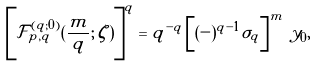<formula> <loc_0><loc_0><loc_500><loc_500>\left [ \mathcal { F } _ { p , q } ^ { ( q ; 0 ) } ( \frac { m } q ; \, \zeta ) \right ] ^ { q } = q ^ { - q } \left [ ( - ) ^ { q - 1 } \sigma _ { q } \right ] ^ { m } \, y _ { 0 } ,</formula> 